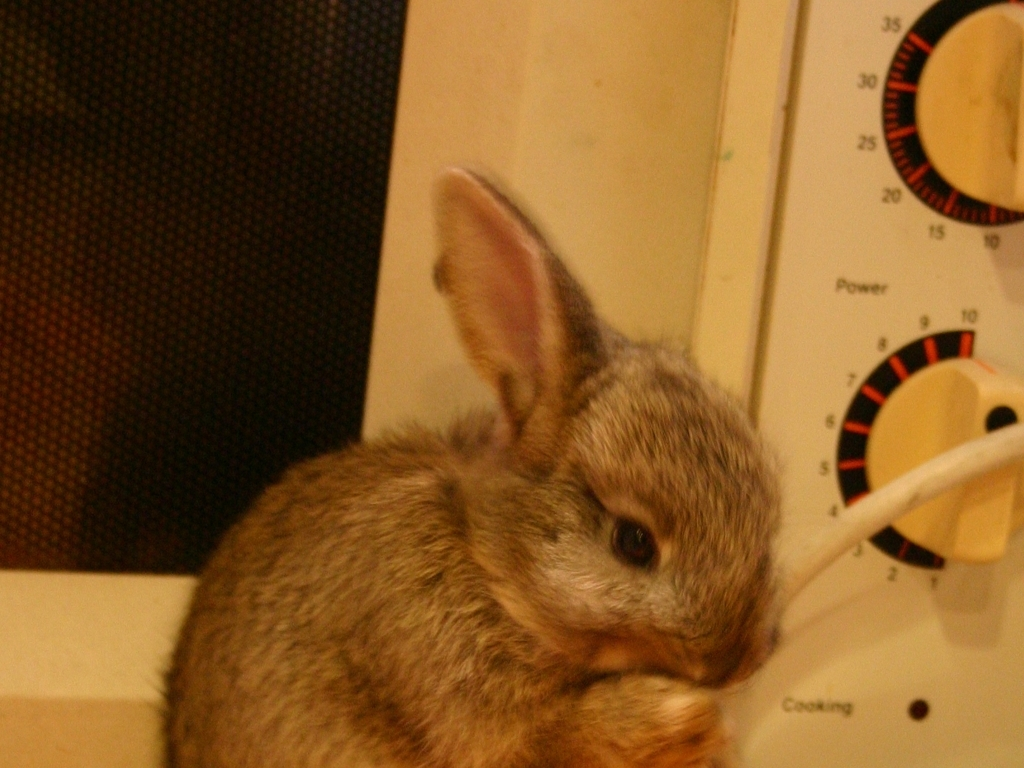What is the color contrast like in the picture? A. Good B. Poor C. Average The color contrast in the image is good, as indicated by the clear distinction between the warm brown tones of the rabbit and the neutral, muted colors of the background. The light-colored rabbit against the drab electronics highlights the subject effectively. 